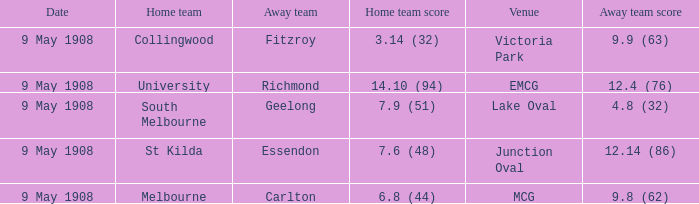Name the home team score for south melbourne home team 7.9 (51). 